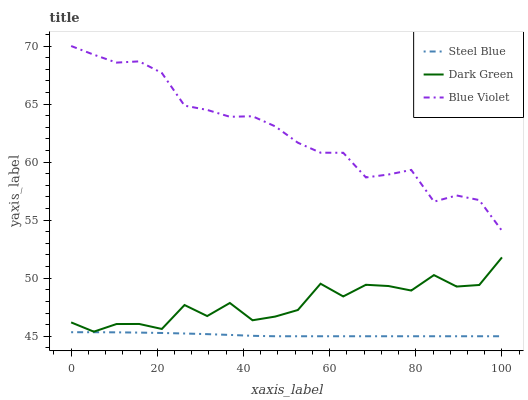Does Steel Blue have the minimum area under the curve?
Answer yes or no. Yes. Does Blue Violet have the maximum area under the curve?
Answer yes or no. Yes. Does Dark Green have the minimum area under the curve?
Answer yes or no. No. Does Dark Green have the maximum area under the curve?
Answer yes or no. No. Is Steel Blue the smoothest?
Answer yes or no. Yes. Is Dark Green the roughest?
Answer yes or no. Yes. Is Blue Violet the smoothest?
Answer yes or no. No. Is Blue Violet the roughest?
Answer yes or no. No. Does Dark Green have the lowest value?
Answer yes or no. No. Does Blue Violet have the highest value?
Answer yes or no. Yes. Does Dark Green have the highest value?
Answer yes or no. No. Is Steel Blue less than Dark Green?
Answer yes or no. Yes. Is Dark Green greater than Steel Blue?
Answer yes or no. Yes. Does Steel Blue intersect Dark Green?
Answer yes or no. No. 